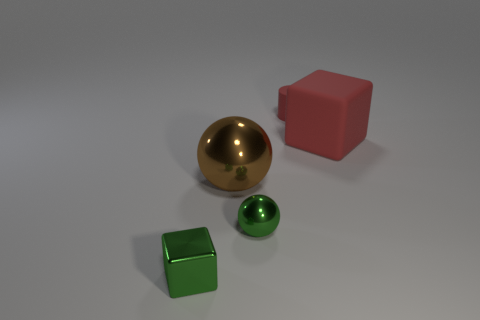Can you comment on the arrangement of the objects in this image? The objects are deliberately arranged to create a balanced composition. The golden sphere is centrally placed, with the smaller green sphere close to it, potentially suggesting a focal point due to its reflective surface and size. The cubes are placed to the side harmoniously, one pink on the right and one green on the left, complementing the spheres without overshadowing them. What might this arrangement suggest about the intended presentation or message of the image? The arrangement could be a study of geometry, color, and light. The symmetric positioning and contrast in colors may suggest an artistic intent or a demonstration of 3D rendering capabilities, focusing on the interplay of shapes and hues in a simple, yet aesthetically pleasing manner. 